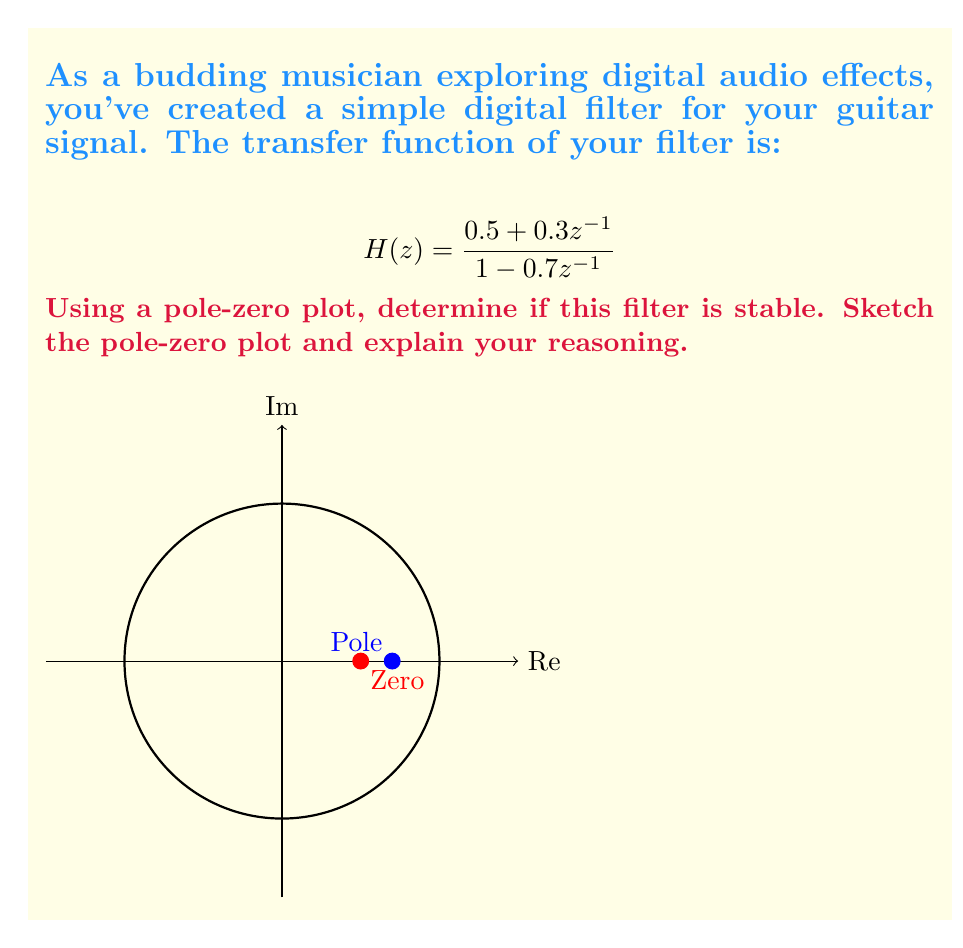Provide a solution to this math problem. To analyze the stability of a digital filter using a pole-zero plot, we follow these steps:

1) Identify the poles and zeros of the transfer function:
   - Zeros: Set the numerator to zero and solve for z
     $0.5 + 0.3z^{-1} = 0$
     $z^{-1} = -\frac{5}{3}$
     $z = -\frac{3}{5} = -0.6$
   - Poles: Set the denominator to zero and solve for z
     $1 - 0.7z^{-1} = 0$
     $z^{-1} = \frac{1}{0.7}$
     $z = 0.7$

2) Plot the poles and zeros on the complex z-plane:
   - Zero at z = -0.6
   - Pole at z = 0.7

3) Draw the unit circle (|z| = 1) on the z-plane.

4) Stability criterion: A digital filter is stable if and only if all its poles lie inside the unit circle.

5) Examine the pole location:
   The pole at z = 0.7 is inside the unit circle (|0.7| < 1).

6) Conclusion:
   Since the only pole of the system is inside the unit circle, the filter is stable.

Note: The location of zeros does not affect the stability of the system, only the poles.
Answer: The filter is stable because its only pole (z = 0.7) lies inside the unit circle. 